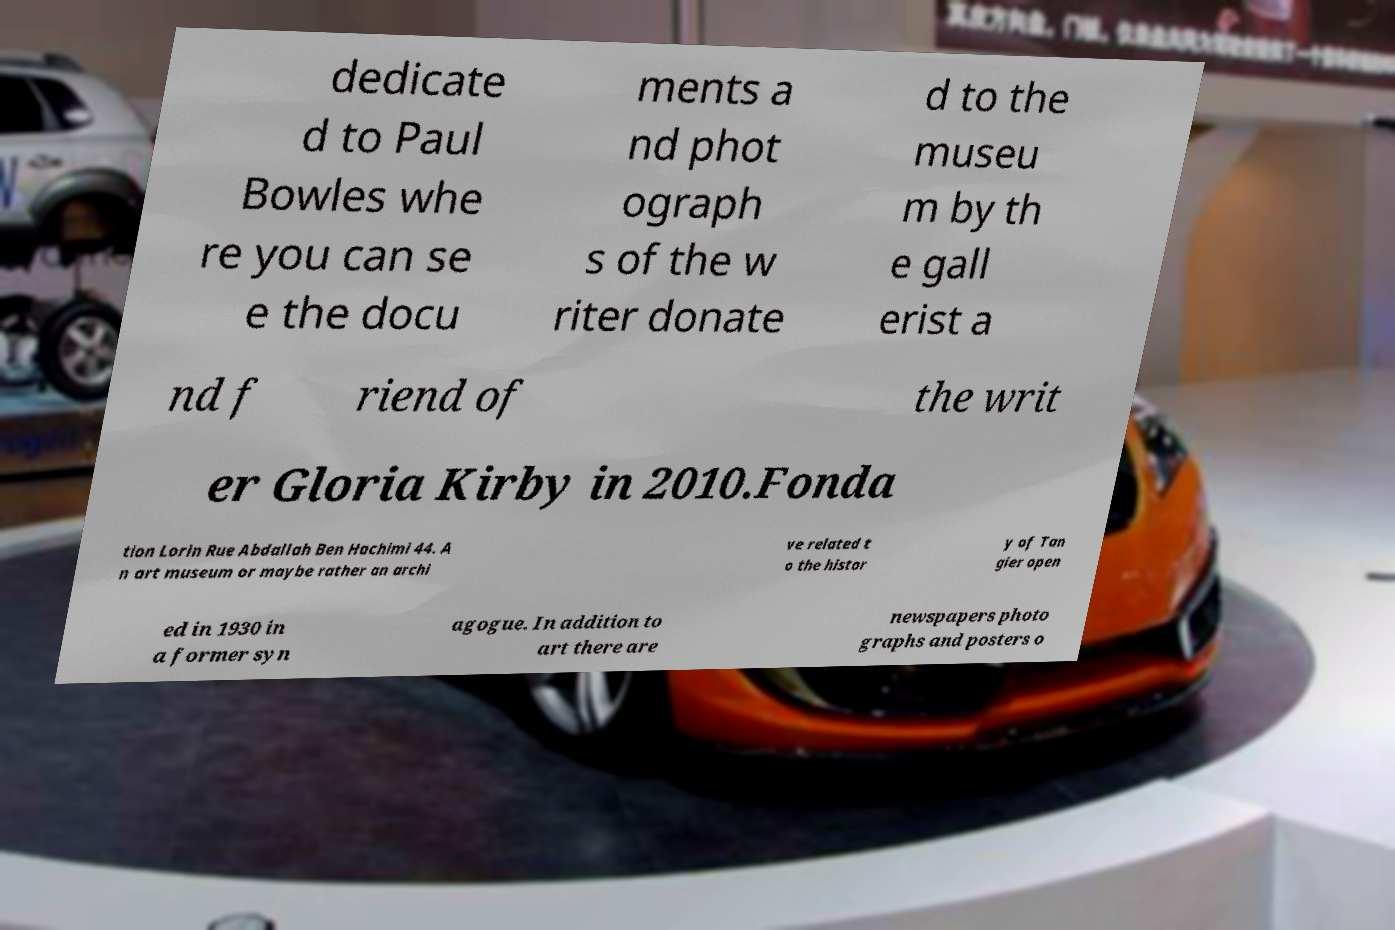I need the written content from this picture converted into text. Can you do that? dedicate d to Paul Bowles whe re you can se e the docu ments a nd phot ograph s of the w riter donate d to the museu m by th e gall erist a nd f riend of the writ er Gloria Kirby in 2010.Fonda tion Lorin Rue Abdallah Ben Hachimi 44. A n art museum or maybe rather an archi ve related t o the histor y of Tan gier open ed in 1930 in a former syn agogue. In addition to art there are newspapers photo graphs and posters o 